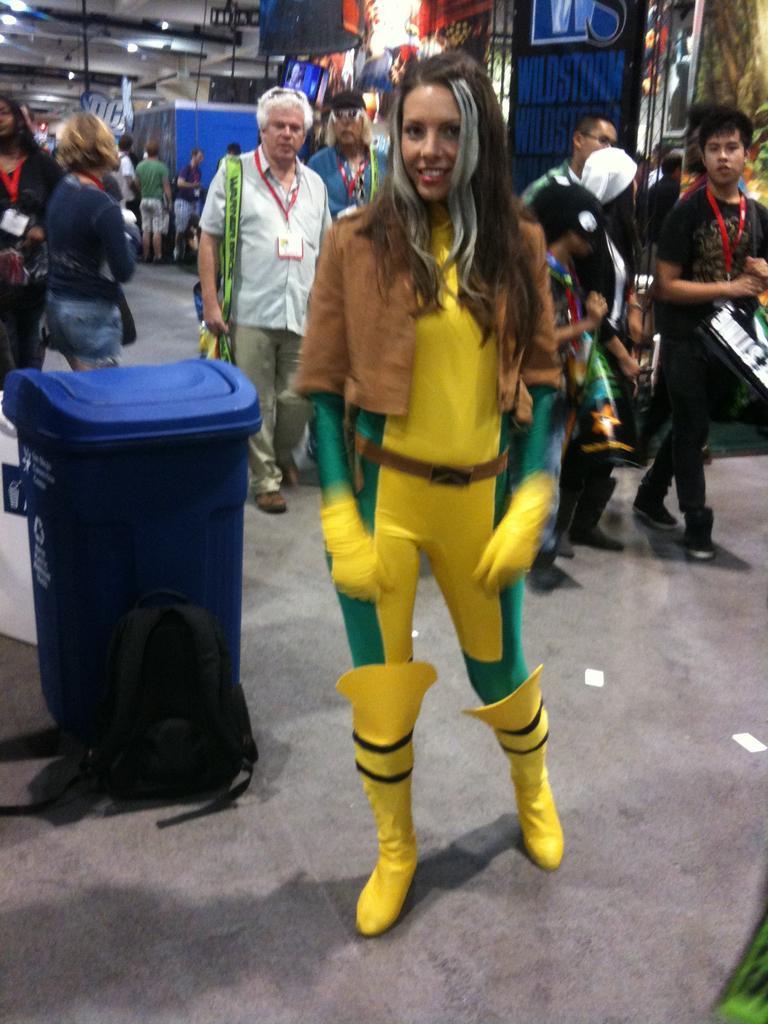Could you give a brief overview of what you see in this image? In this picture we can see a woman, dustbin and a bag on the ground and in the background we can see a group of people, lights and some objects. 